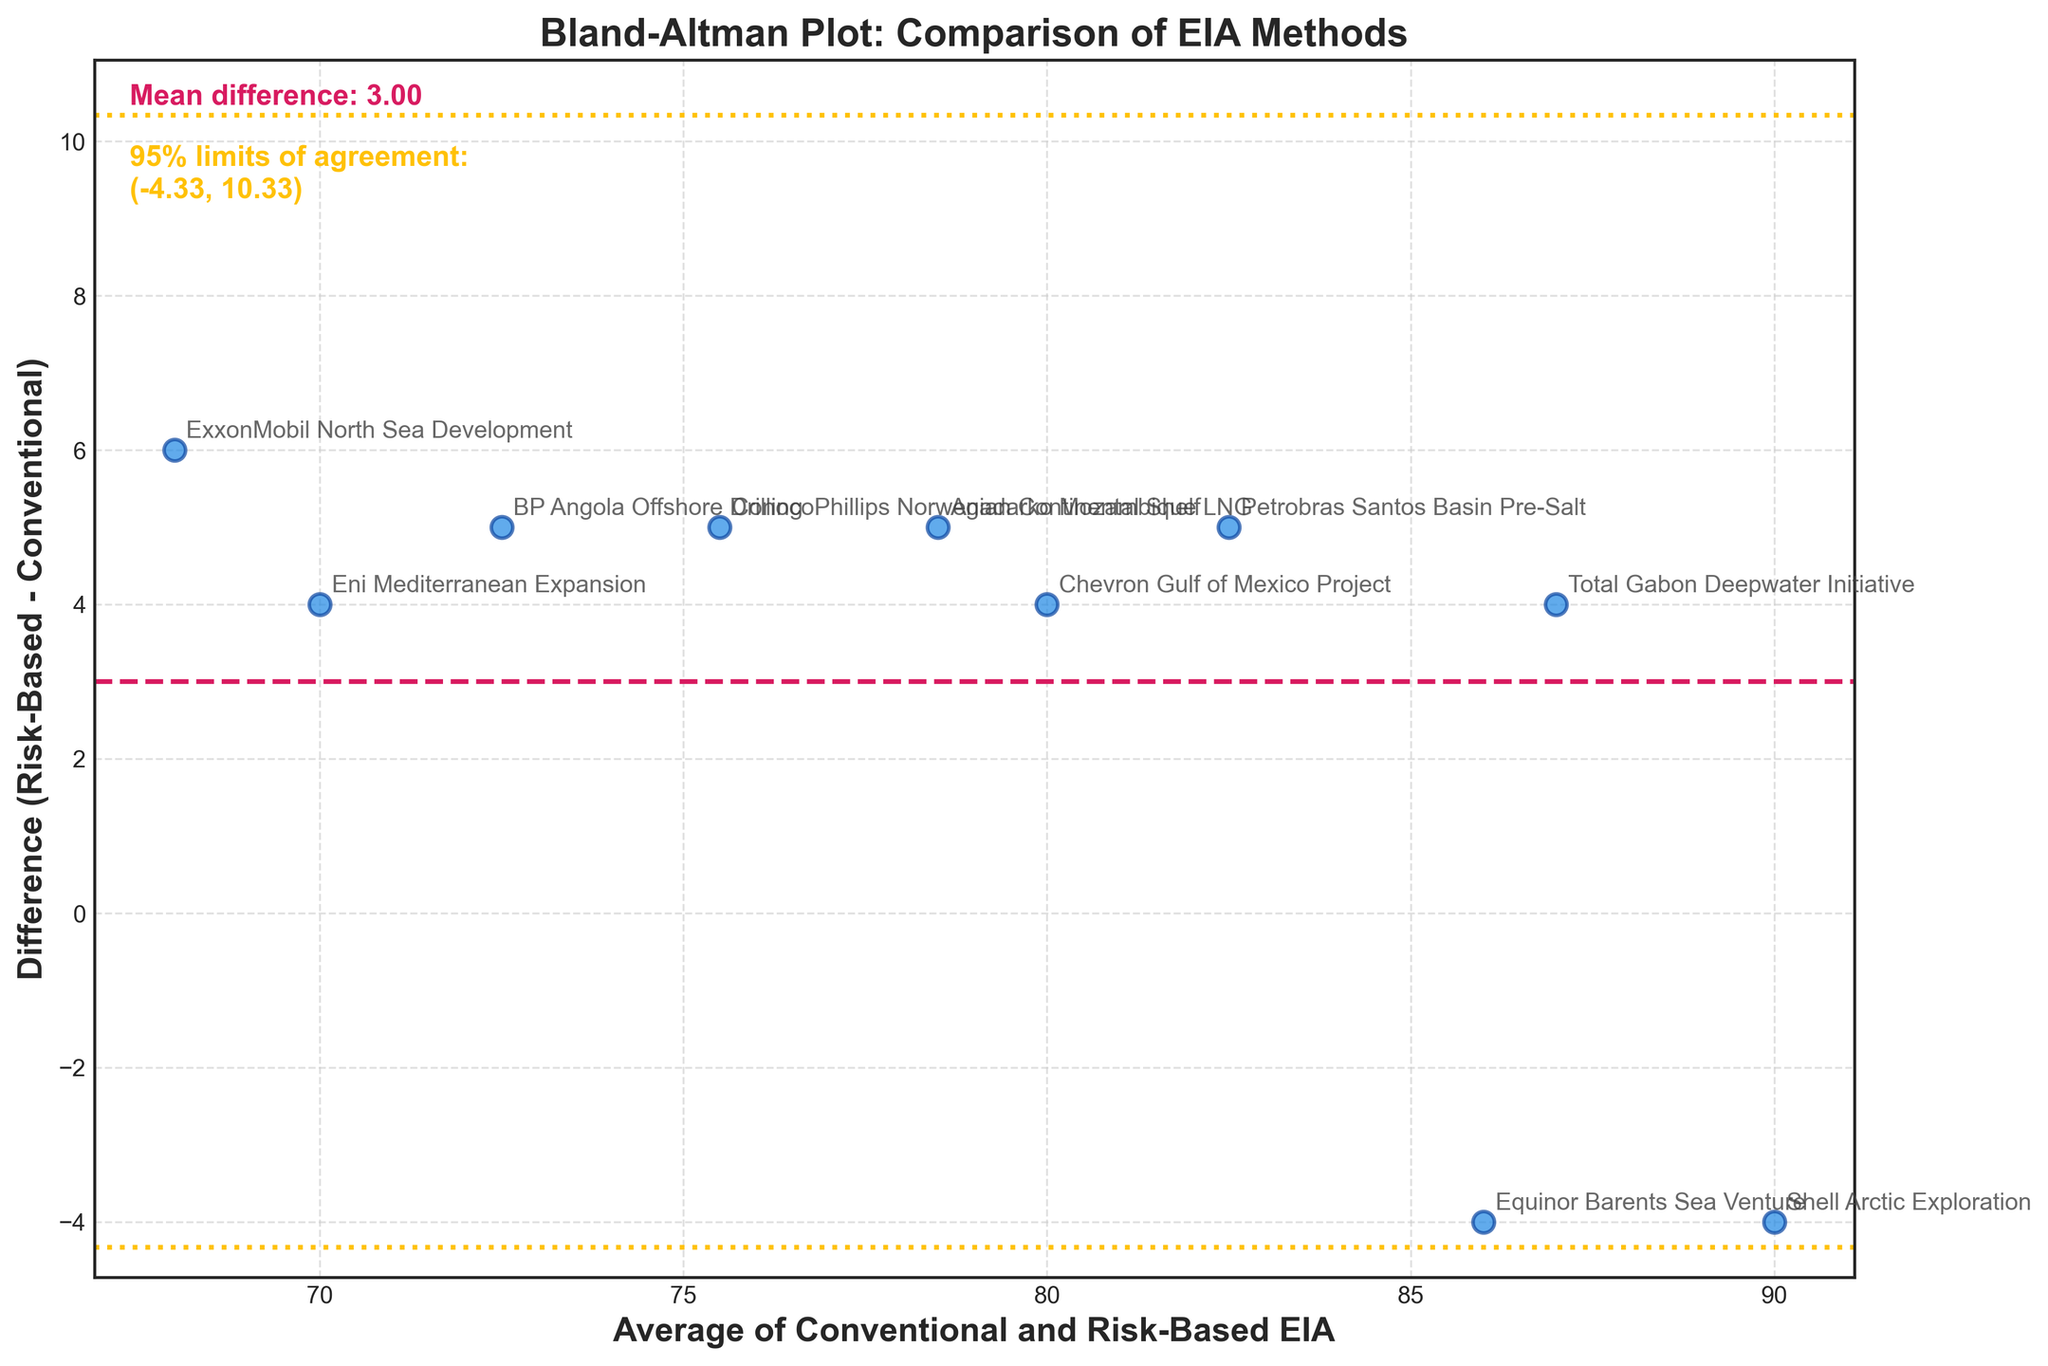What is the title of the plot? The title is usually located at the top of the plot and is displayed in a large, bold font to attract attention.
Answer: Bland-Altman Plot: Comparison of EIA Methods How many data points are plotted on the graph? To determine the number of data points, visually count all the scattered points on the plot.
Answer: 10 What do the dashed and dotted lines on the plot indicate? The dashed line represents the mean difference between the two methods, and the dotted lines represent the 95% limits of agreement.
Answer: Mean difference and 95% limits of agreement What is the mean difference value displayed on the plot? The mean difference value is provided in the text annotation, usually located near the top of the plot.
Answer: 3.60 What are the 95% limits of agreement for the differences? The limits of agreement are directly provided in the text annotation: (-0.79, 7.99)
Answer: (-0.79, 7.99) Which project has the highest positive difference between the two methods? Examine the y-axis to find the highest scattered point above the zero line, then refer to the annotation on that point.
Answer: ExxonMobil North Sea Development Which project recorded a negative difference in the plot? Locate the points below the zero line on the y-axis and read the corresponding annotations.
Answer: Shell Arctic Exploration, Equinor Barents Sea Venture What is the average value of EIA assessments for the Equinor Barents Sea Venture project? Look for the annotated point for Equinor Barents Sea Venture and read the x-axis value.
Answer: 86 How does the mean difference compare to the zero line on the y-axis? Observe the position of the dashed line (mean difference) relative to the zero line (y-axis). Is it above, below, or coincident with the zero line?
Answer: Above Which projects have a difference value of 5 between the methods? Identify the points on the plot where the y-axis value equals 5 and read the corresponding annotations.
Answer: BP Angola Offshore Drilling, ConocoPhillips Norwegian Continental Shelf, Petrobras Santos Basin Pre-Salt, Anadarko Mozambique LNG 